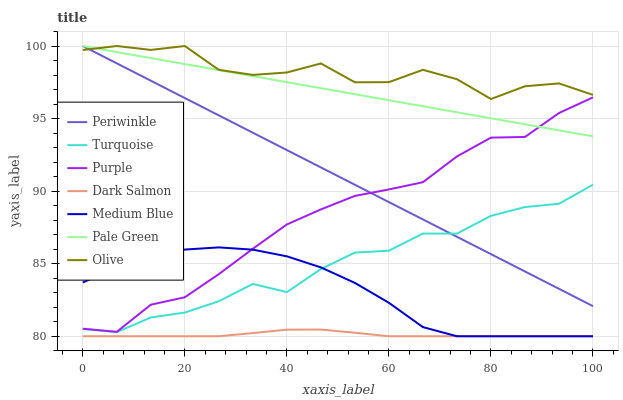Does Dark Salmon have the minimum area under the curve?
Answer yes or no. Yes. Does Olive have the maximum area under the curve?
Answer yes or no. Yes. Does Purple have the minimum area under the curve?
Answer yes or no. No. Does Purple have the maximum area under the curve?
Answer yes or no. No. Is Periwinkle the smoothest?
Answer yes or no. Yes. Is Olive the roughest?
Answer yes or no. Yes. Is Purple the smoothest?
Answer yes or no. No. Is Purple the roughest?
Answer yes or no. No. Does Medium Blue have the lowest value?
Answer yes or no. Yes. Does Purple have the lowest value?
Answer yes or no. No. Does Olive have the highest value?
Answer yes or no. Yes. Does Purple have the highest value?
Answer yes or no. No. Is Dark Salmon less than Periwinkle?
Answer yes or no. Yes. Is Periwinkle greater than Dark Salmon?
Answer yes or no. Yes. Does Pale Green intersect Periwinkle?
Answer yes or no. Yes. Is Pale Green less than Periwinkle?
Answer yes or no. No. Is Pale Green greater than Periwinkle?
Answer yes or no. No. Does Dark Salmon intersect Periwinkle?
Answer yes or no. No. 